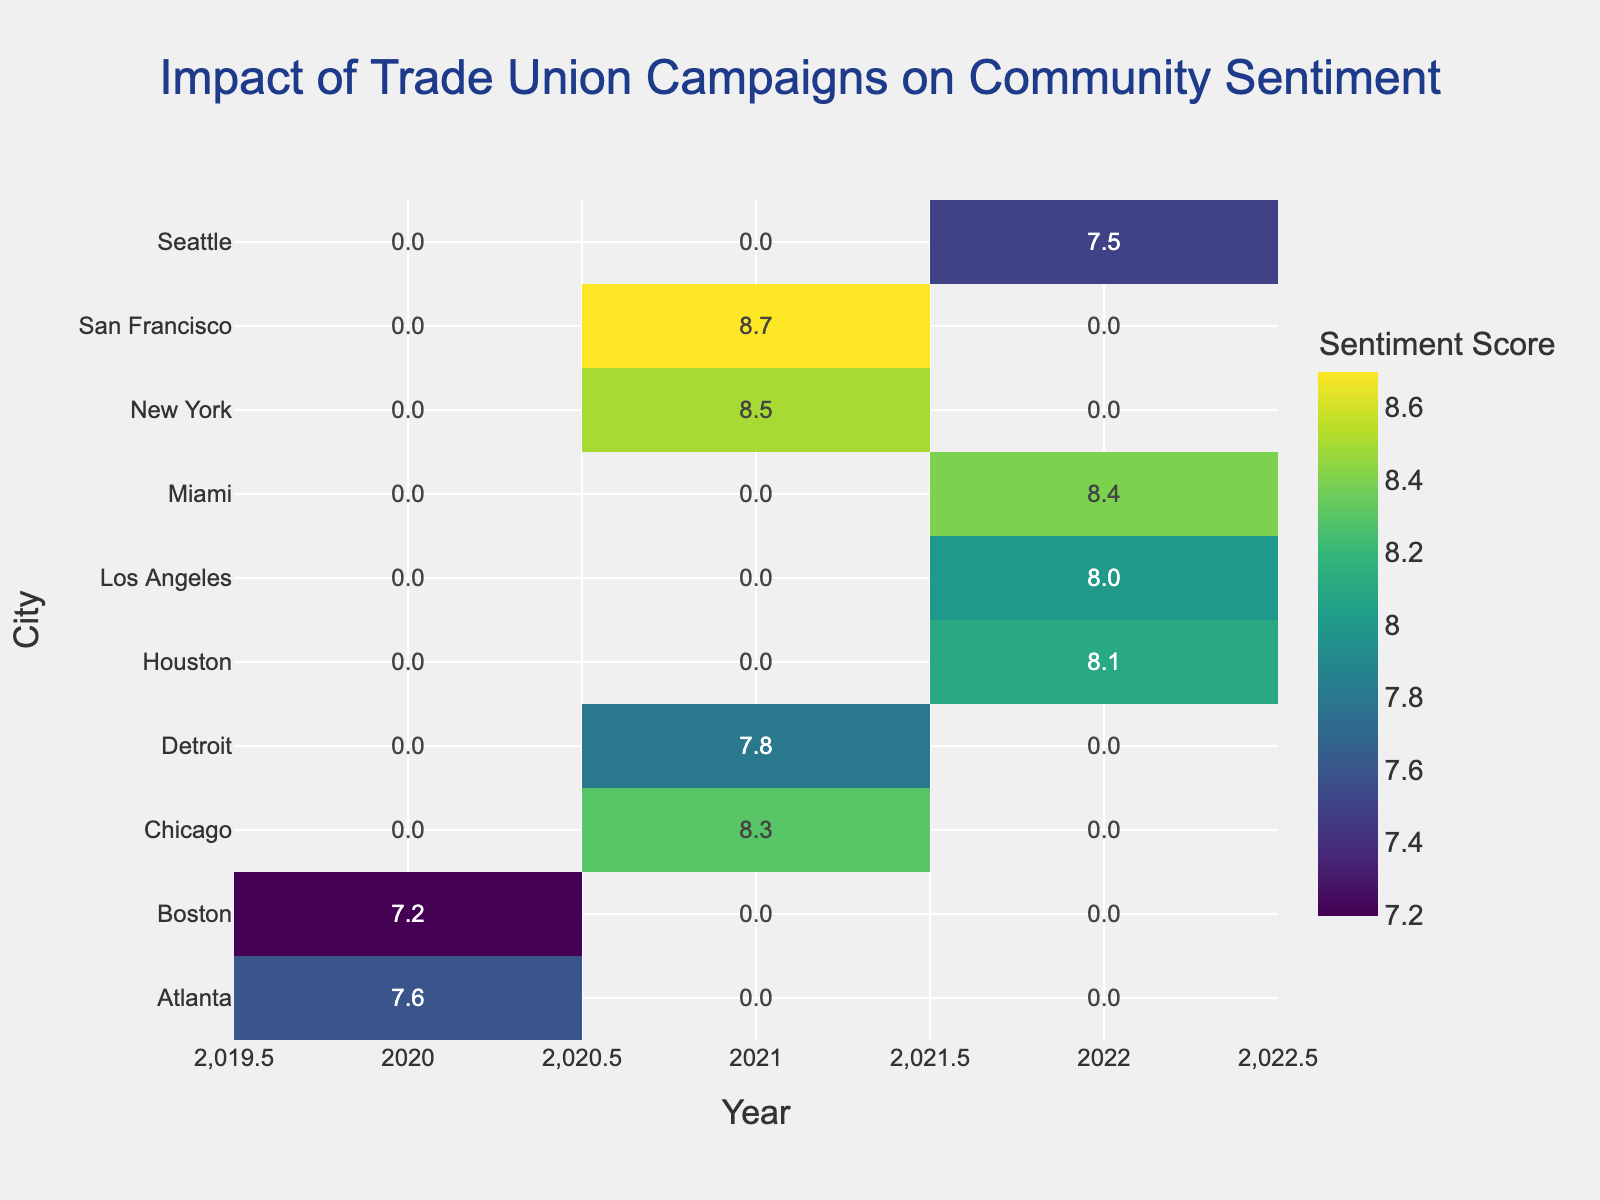Which city had the highest community sentiment score in 2021? To find the city with the highest sentiment score in 2021, look at the sentiment scores for each city in the year 2021 column. The highest value is 8.7 in San Francisco.
Answer: San Francisco What is the average community sentiment score in 2022 across all cities? To determine the average community sentiment score in 2022, sum the scores for 2022 (8.0 + 7.5 + 8.1 + 8.4) and divide by the number of scores. That is (8.0 + 7.5 + 8.1 + 8.4) / 4 = 8.0.
Answer: 8.0 Which year had the lowest overall community sentiment score? To find the year with the lowest overall sentiment score, compare the sentiment scores for all years. The lowest overall score is 7.2 in Boston for 2020.
Answer: 2020 Comparing the sentiment scores for Detroit across all years, which year had the highest score? To compare, look at the sentiment scores for Detroit across all years. There is only one value for Detroit - 7.8 in 2021, which is the highest for Detroit.
Answer: 2021 Which campaign type led to the highest community sentiment score? From the given data, the "Equal Pay Movement" campaign in San Francisco in 2021 led to the highest community sentiment score of 8.7.
Answer: Equal Pay Movement How did the community sentiment in New York change from 2021 to 2022? There is only one data point for New York in 2021 with no corresponding point in 2022; thus, the change is not applicable.
Answer: Not applicable In which city and year was community sentiment the lowest? To find the city and year with the lowest sentiment, locate the lowest value in the heatmap. The lowest sentiment is 7.2 in Boston in 2020.
Answer: Boston, 2020 How does the sentiment score of Seattle in 2022 compare to that of Miami in the same year? Compare the sentiment scores for Seattle and Miami in 2022. Seattle's score is 7.5, while Miami's score is 8.4. Thus, Miami has a higher sentiment score than Seattle.
Answer: Miami is higher Which year had the highest variation in community sentiment scores across different cities? To find the year with the highest variation, visually inspect the differences in sentiment scores for each year. The year 2021 shows more diverse values, ranging from 7.8 in Detroit to 8.7 in San Francisco.
Answer: 2021 What was the impact on community sentiment in Los Angeles in 2022 and how does it compare to Chicago in 2021? Los Angeles had a community sentiment score of 8.0 in 2022, while Chicago had a score of 8.3 in 2021. Thus, Chicago's score was higher compared to Los Angeles' score.
Answer: Chicago in 2021 was higher 